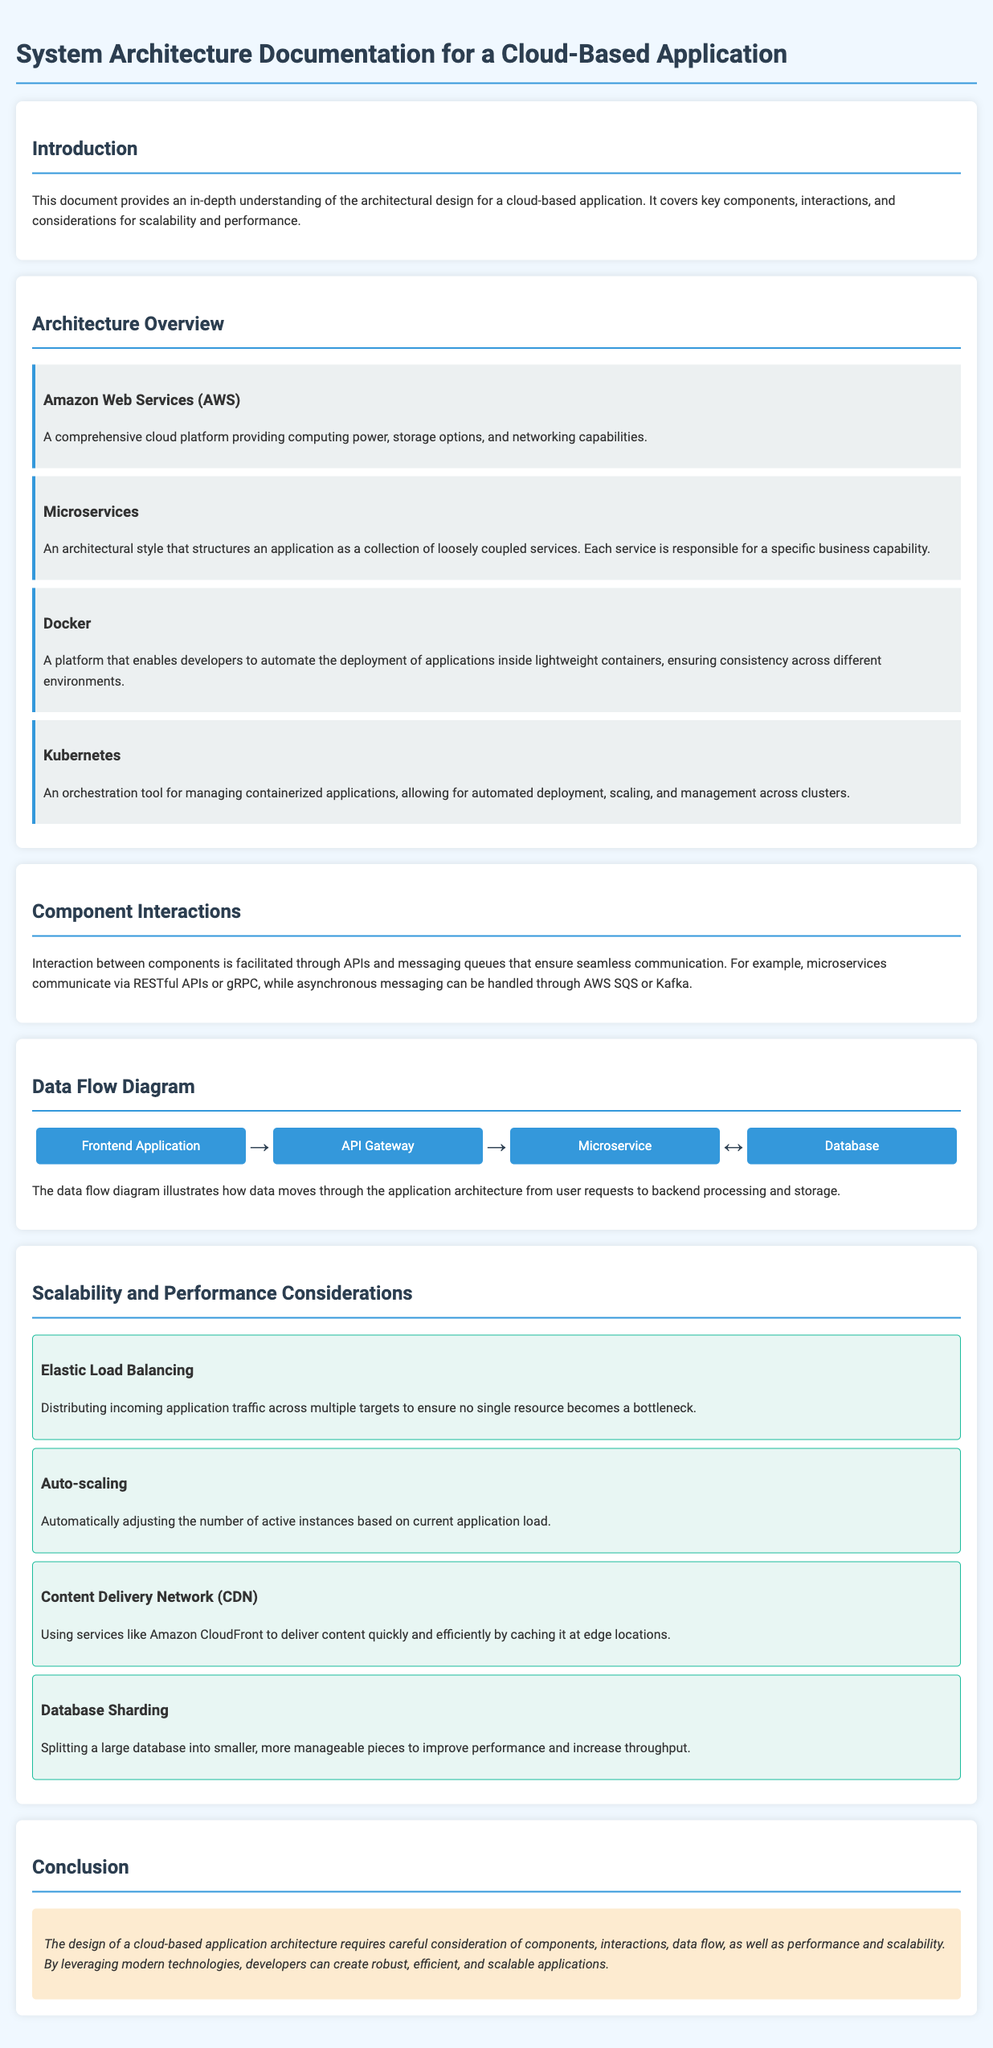What is the title of the document? The title of the document is specified in the HTML head section.
Answer: System Architecture Documentation for a Cloud-Based Application What architectural style does the document emphasize? The document highlights an architectural style in the component section.
Answer: Microservices What tool is used for orchestration of containerized applications? The document mentions a specific tool for orchestration in the component section.
Answer: Kubernetes Which AWS service is mentioned as a comprehensive cloud platform? The document identifies a specific AWS service providing cloud capabilities.
Answer: Amazon Web Services What type of balancing is recommended to handle application traffic? The document discusses a strategy to distribute traffic in the scalability section.
Answer: Elastic Load Balancing What is the purpose of database sharding as mentioned in the document? The document outlines a specific method for improving performance and increasing throughput.
Answer: Improve performance and increase throughput What does the flow diagram illustrate? The diagram is described in relation to user requests and backend processing.
Answer: How data moves through the application architecture Which CDN is suggested for efficient content delivery? The document recommends a specific service for content delivery in the scalability section.
Answer: Amazon CloudFront 